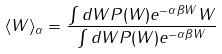Convert formula to latex. <formula><loc_0><loc_0><loc_500><loc_500>\langle W \rangle _ { \alpha } = \frac { \int d W P ( W ) e ^ { - \alpha \beta W } W } { \int d W P ( W ) e ^ { - \alpha \beta W } }</formula> 